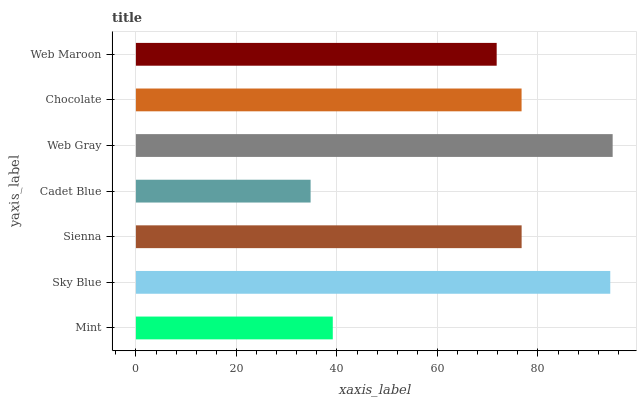Is Cadet Blue the minimum?
Answer yes or no. Yes. Is Web Gray the maximum?
Answer yes or no. Yes. Is Sky Blue the minimum?
Answer yes or no. No. Is Sky Blue the maximum?
Answer yes or no. No. Is Sky Blue greater than Mint?
Answer yes or no. Yes. Is Mint less than Sky Blue?
Answer yes or no. Yes. Is Mint greater than Sky Blue?
Answer yes or no. No. Is Sky Blue less than Mint?
Answer yes or no. No. Is Chocolate the high median?
Answer yes or no. Yes. Is Chocolate the low median?
Answer yes or no. Yes. Is Cadet Blue the high median?
Answer yes or no. No. Is Web Gray the low median?
Answer yes or no. No. 